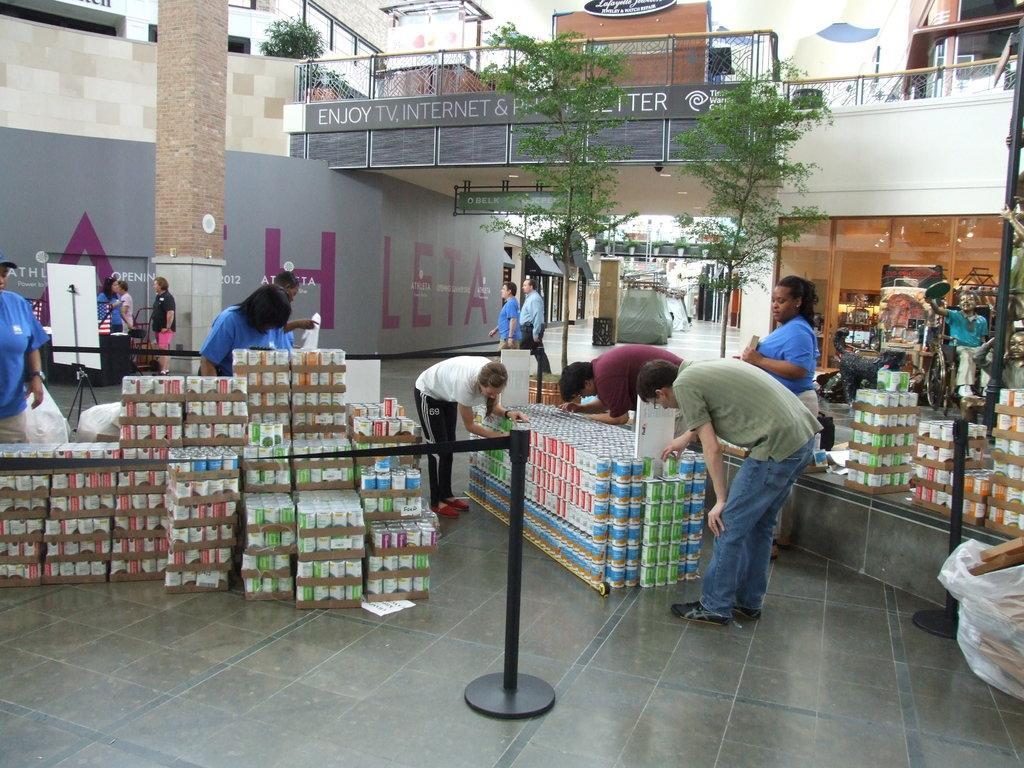Can you describe this image briefly? In this image I can see the ground, few black colored poles, black colored belt to the poles, few objects which are white, orange, blue and green in color on the ground and few persons are standing and holding them. In the background I can see few buildings, the bridge, few trees which are green in color, few boards and few other objects. 